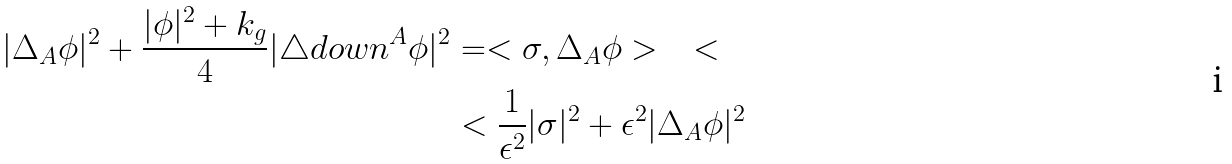Convert formula to latex. <formula><loc_0><loc_0><loc_500><loc_500>| \Delta _ { A } \phi | ^ { 2 } + \frac { | \phi | ^ { 2 } + k _ { g } } { 4 } | \triangle d o w n ^ { A } \phi | ^ { 2 } & = < \sigma , \Delta _ { A } \phi > \quad < \\ & < \frac { 1 } { \epsilon ^ { 2 } } | \sigma | ^ { 2 } + \epsilon ^ { 2 } | \Delta _ { A } \phi | ^ { 2 }</formula> 